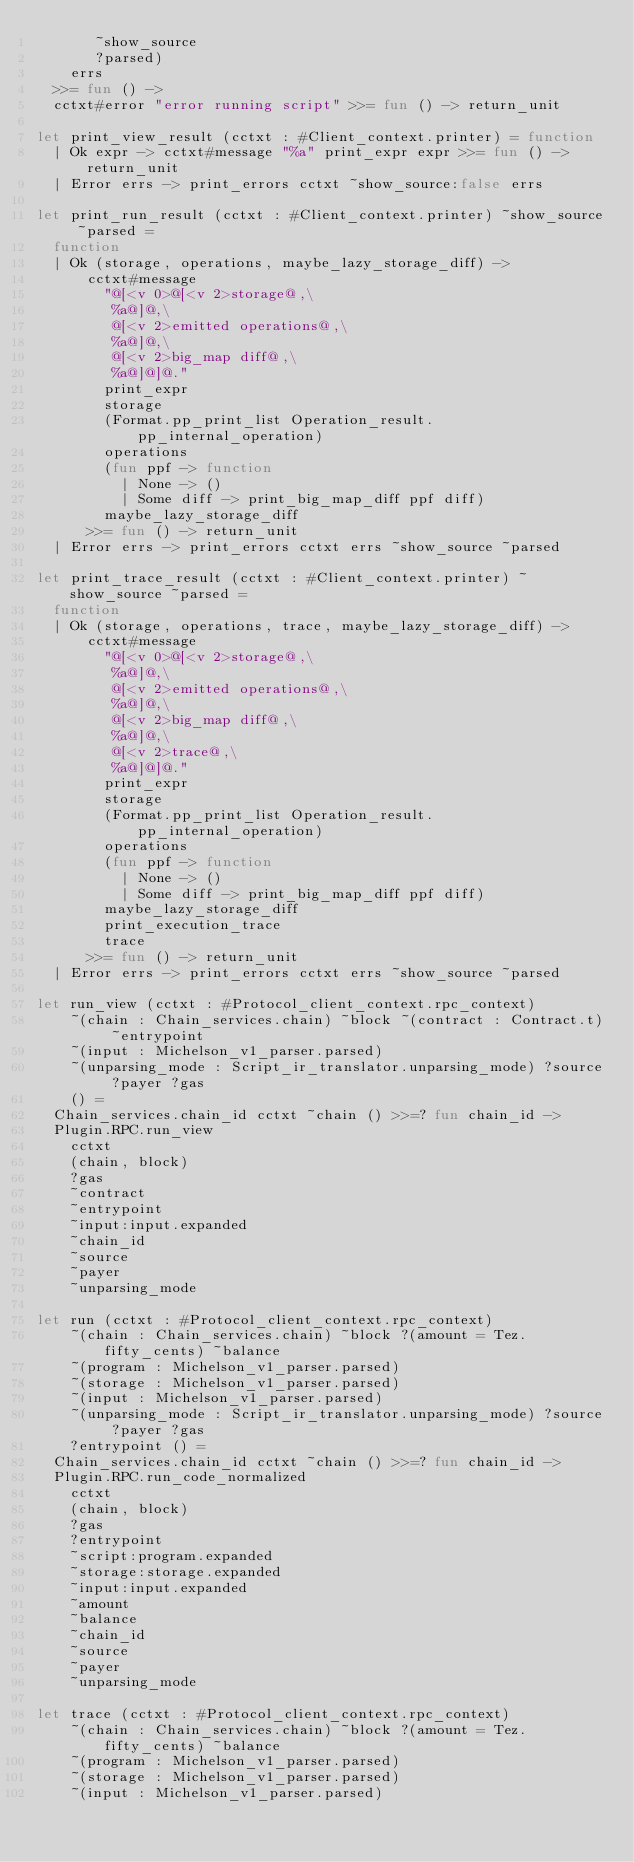Convert code to text. <code><loc_0><loc_0><loc_500><loc_500><_OCaml_>       ~show_source
       ?parsed)
    errs
  >>= fun () ->
  cctxt#error "error running script" >>= fun () -> return_unit

let print_view_result (cctxt : #Client_context.printer) = function
  | Ok expr -> cctxt#message "%a" print_expr expr >>= fun () -> return_unit
  | Error errs -> print_errors cctxt ~show_source:false errs

let print_run_result (cctxt : #Client_context.printer) ~show_source ~parsed =
  function
  | Ok (storage, operations, maybe_lazy_storage_diff) ->
      cctxt#message
        "@[<v 0>@[<v 2>storage@,\
         %a@]@,\
         @[<v 2>emitted operations@,\
         %a@]@,\
         @[<v 2>big_map diff@,\
         %a@]@]@."
        print_expr
        storage
        (Format.pp_print_list Operation_result.pp_internal_operation)
        operations
        (fun ppf -> function
          | None -> ()
          | Some diff -> print_big_map_diff ppf diff)
        maybe_lazy_storage_diff
      >>= fun () -> return_unit
  | Error errs -> print_errors cctxt errs ~show_source ~parsed

let print_trace_result (cctxt : #Client_context.printer) ~show_source ~parsed =
  function
  | Ok (storage, operations, trace, maybe_lazy_storage_diff) ->
      cctxt#message
        "@[<v 0>@[<v 2>storage@,\
         %a@]@,\
         @[<v 2>emitted operations@,\
         %a@]@,\
         @[<v 2>big_map diff@,\
         %a@]@,\
         @[<v 2>trace@,\
         %a@]@]@."
        print_expr
        storage
        (Format.pp_print_list Operation_result.pp_internal_operation)
        operations
        (fun ppf -> function
          | None -> ()
          | Some diff -> print_big_map_diff ppf diff)
        maybe_lazy_storage_diff
        print_execution_trace
        trace
      >>= fun () -> return_unit
  | Error errs -> print_errors cctxt errs ~show_source ~parsed

let run_view (cctxt : #Protocol_client_context.rpc_context)
    ~(chain : Chain_services.chain) ~block ~(contract : Contract.t) ~entrypoint
    ~(input : Michelson_v1_parser.parsed)
    ~(unparsing_mode : Script_ir_translator.unparsing_mode) ?source ?payer ?gas
    () =
  Chain_services.chain_id cctxt ~chain () >>=? fun chain_id ->
  Plugin.RPC.run_view
    cctxt
    (chain, block)
    ?gas
    ~contract
    ~entrypoint
    ~input:input.expanded
    ~chain_id
    ~source
    ~payer
    ~unparsing_mode

let run (cctxt : #Protocol_client_context.rpc_context)
    ~(chain : Chain_services.chain) ~block ?(amount = Tez.fifty_cents) ~balance
    ~(program : Michelson_v1_parser.parsed)
    ~(storage : Michelson_v1_parser.parsed)
    ~(input : Michelson_v1_parser.parsed)
    ~(unparsing_mode : Script_ir_translator.unparsing_mode) ?source ?payer ?gas
    ?entrypoint () =
  Chain_services.chain_id cctxt ~chain () >>=? fun chain_id ->
  Plugin.RPC.run_code_normalized
    cctxt
    (chain, block)
    ?gas
    ?entrypoint
    ~script:program.expanded
    ~storage:storage.expanded
    ~input:input.expanded
    ~amount
    ~balance
    ~chain_id
    ~source
    ~payer
    ~unparsing_mode

let trace (cctxt : #Protocol_client_context.rpc_context)
    ~(chain : Chain_services.chain) ~block ?(amount = Tez.fifty_cents) ~balance
    ~(program : Michelson_v1_parser.parsed)
    ~(storage : Michelson_v1_parser.parsed)
    ~(input : Michelson_v1_parser.parsed)</code> 